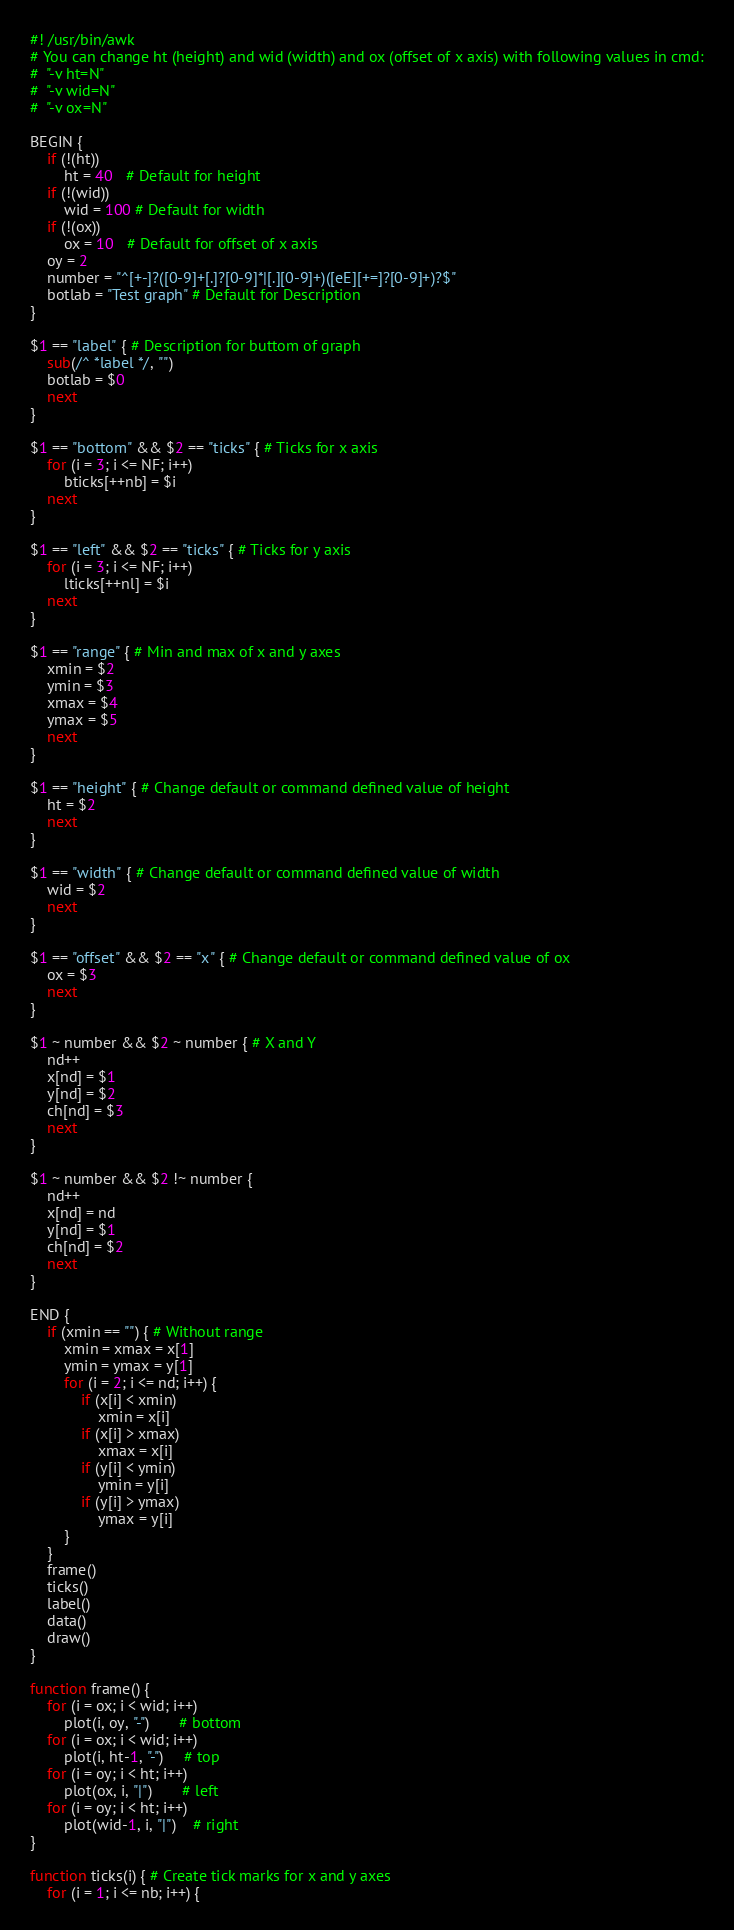Convert code to text. <code><loc_0><loc_0><loc_500><loc_500><_Awk_>#! /usr/bin/awk
# You can change ht (height) and wid (width) and ox (offset of x axis) with following values in cmd:
#  "-v ht=N"
#  "-v wid=N" 
#  "-v ox=N"

BEGIN {
	if (!(ht))
		ht = 40   # Default for height
	if (!(wid))
		wid = 100 # Default for width
	if (!(ox))
		ox = 10   # Default for offset of x axis
	oy = 2
	number = "^[+-]?([0-9]+[.]?[0-9]*|[.][0-9]+)([eE][+=]?[0-9]+)?$"
	botlab = "Test graph" # Default for Description 
}

$1 == "label" { # Description for buttom of graph
	sub(/^ *label */, "")
	botlab = $0
	next
}

$1 == "bottom" && $2 == "ticks" { # Ticks for x axis
	for (i = 3; i <= NF; i++)
		bticks[++nb] = $i
	next
}

$1 == "left" && $2 == "ticks" { # Ticks for y axis
	for (i = 3; i <= NF; i++)
		lticks[++nl] = $i
	next
}

$1 == "range" { # Min and max of x and y axes
	xmin = $2
	ymin = $3
	xmax = $4
	ymax = $5
	next
}

$1 == "height" { # Change default or command defined value of height
	ht = $2
	next
}

$1 == "width" { # Change default or command defined value of width
	wid = $2
	next
}

$1 == "offset" && $2 == "x" { # Change default or command defined value of ox
	ox = $3
	next
}

$1 ~ number && $2 ~ number { # X and Y
	nd++
	x[nd] = $1
	y[nd] = $2
	ch[nd] = $3
	next
}

$1 ~ number && $2 !~ number {
	nd++
	x[nd] = nd
	y[nd] = $1
	ch[nd] = $2
	next
}

END {
	if (xmin == "") { # Without range
		xmin = xmax = x[1]
		ymin = ymax = y[1]
		for (i = 2; i <= nd; i++) {
			if (x[i] < xmin)
				xmin = x[i]
			if (x[i] > xmax) 
				xmax = x[i]
			if (y[i] < ymin)
				ymin = y[i]
			if (y[i] > ymax) 
				ymax = y[i]
		}
	}
	frame()
	ticks()
	label()
	data()
	draw()
}

function frame() {
	for (i = ox; i < wid; i++)
		plot(i, oy, "-")       # bottom
	for (i = ox; i < wid; i++)
		plot(i, ht-1, "-")     # top
	for (i = oy; i < ht; i++)
		plot(ox, i, "|")       # left
	for (i = oy; i < ht; i++)
		plot(wid-1, i, "|")    # right
}

function ticks(i) { # Create tick marks for x and y axes
	for (i = 1; i <= nb; i++) {</code> 